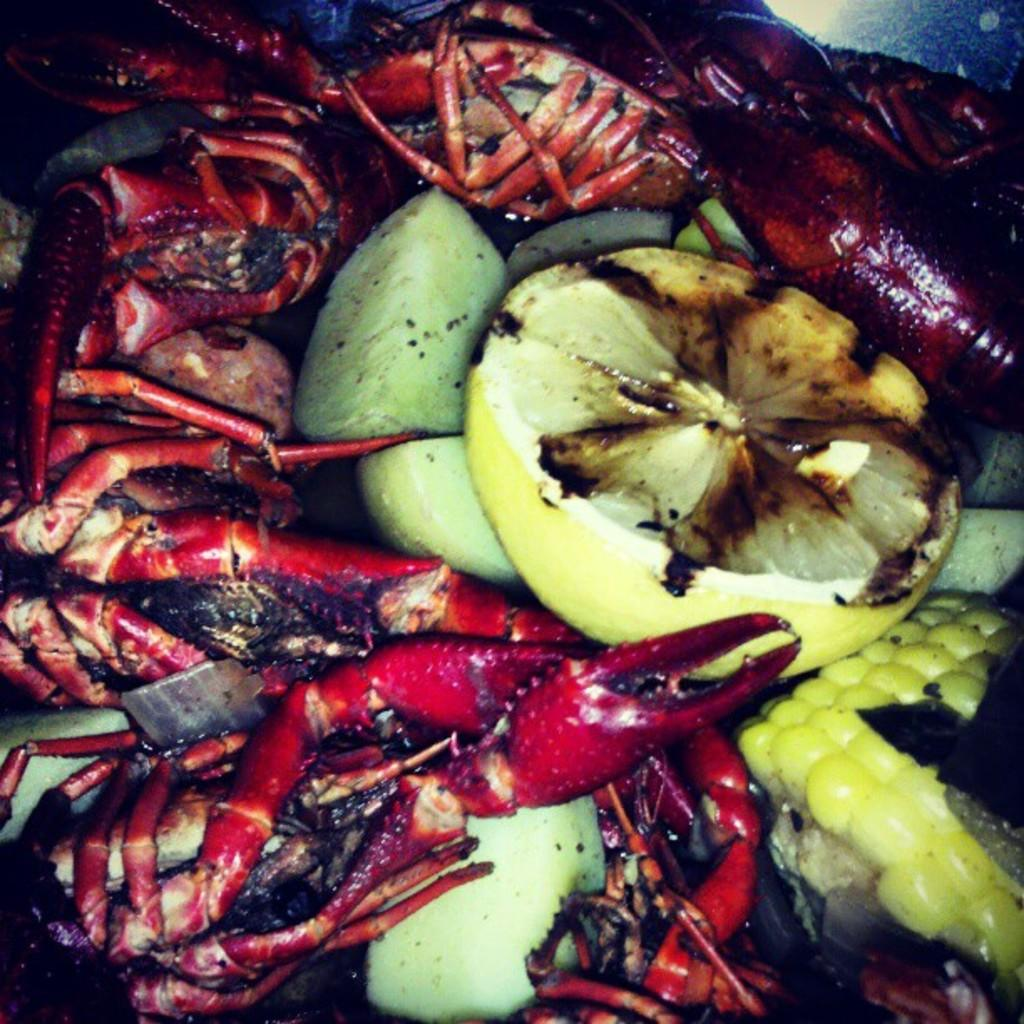What is present on the surface in the image? There is food placed on a surface in the image. What type of learning is taking place in the image? There is no indication of any learning taking place in the image; it only shows food placed on a surface. 